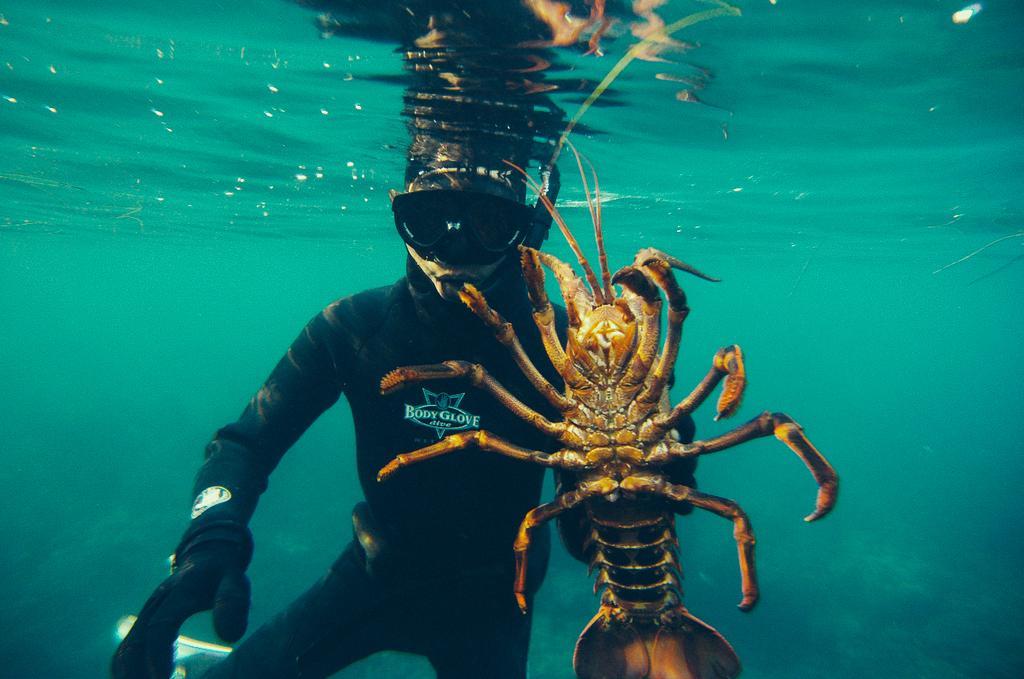How would you summarize this image in a sentence or two? As we can see in the image there is water. In water there is a person wearing black color jacket and there is an insect. 